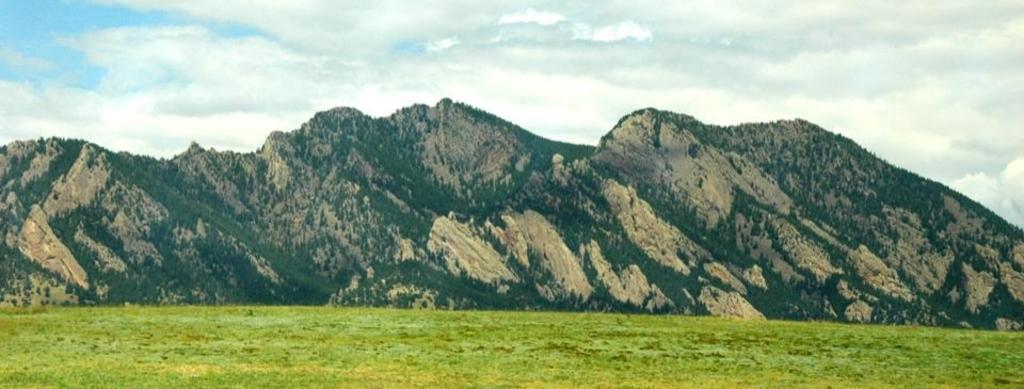What type of vegetation can be seen in the image? There is grass and trees in the image. What geographical features are present in the image? There are hills in the image. What is the condition of the sky in the image? The sky appears to be cloudy in the image. Can you see a hole in the grass in the image? There is no hole visible in the grass in the image. What type of bone is present in the image? There are no bones present in the image. 